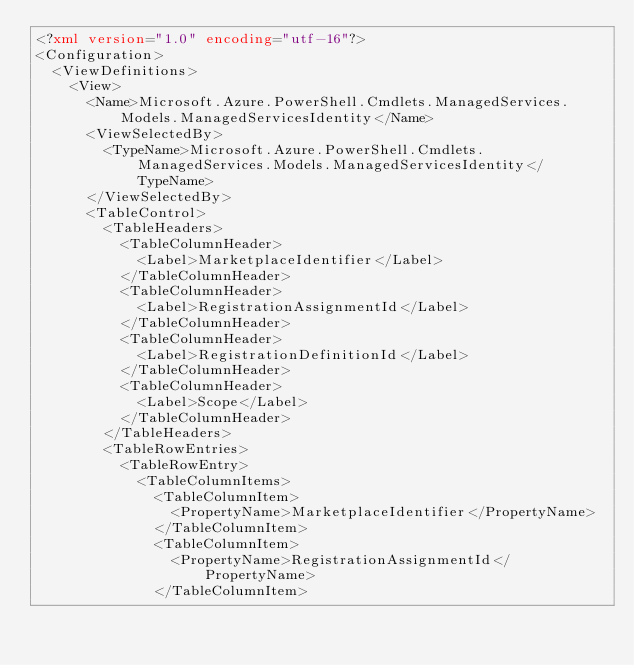<code> <loc_0><loc_0><loc_500><loc_500><_XML_><?xml version="1.0" encoding="utf-16"?>
<Configuration>
  <ViewDefinitions>
    <View>
      <Name>Microsoft.Azure.PowerShell.Cmdlets.ManagedServices.Models.ManagedServicesIdentity</Name>
      <ViewSelectedBy>
        <TypeName>Microsoft.Azure.PowerShell.Cmdlets.ManagedServices.Models.ManagedServicesIdentity</TypeName>
      </ViewSelectedBy>
      <TableControl>
        <TableHeaders>
          <TableColumnHeader>
            <Label>MarketplaceIdentifier</Label>
          </TableColumnHeader>
          <TableColumnHeader>
            <Label>RegistrationAssignmentId</Label>
          </TableColumnHeader>
          <TableColumnHeader>
            <Label>RegistrationDefinitionId</Label>
          </TableColumnHeader>
          <TableColumnHeader>
            <Label>Scope</Label>
          </TableColumnHeader>
        </TableHeaders>
        <TableRowEntries>
          <TableRowEntry>
            <TableColumnItems>
              <TableColumnItem>
                <PropertyName>MarketplaceIdentifier</PropertyName>
              </TableColumnItem>
              <TableColumnItem>
                <PropertyName>RegistrationAssignmentId</PropertyName>
              </TableColumnItem></code> 